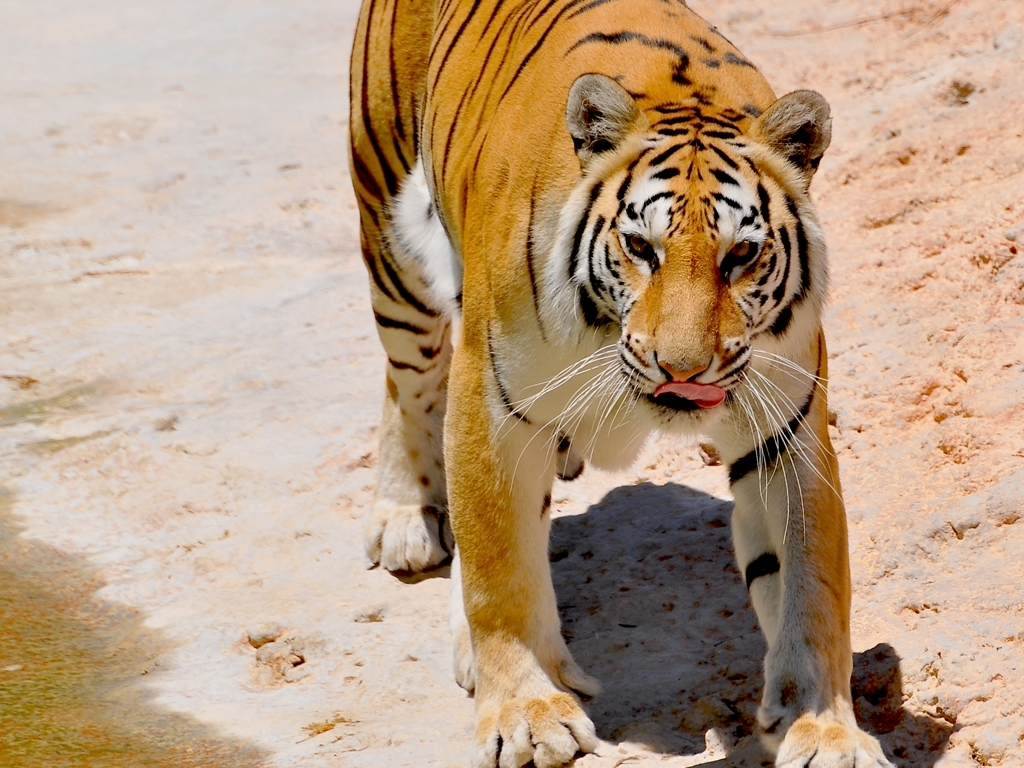What behavior might the tiger be exhibiting in this photo? The tiger's direct gaze and orientation towards the camera suggest it may be curious about or reacting to the photographer's presence. Its mouth is slightly open, which could mean it's panting due to heat or physical exertion, or it may be displaying a flehmen response, a behavior used to smell or taste the air. 